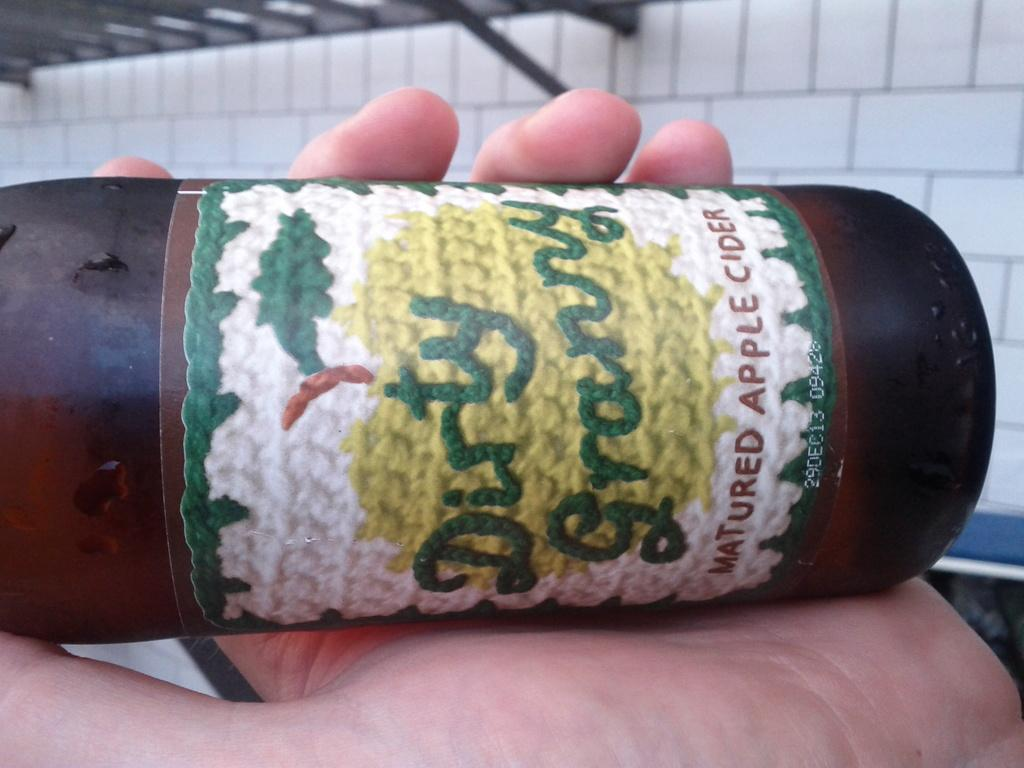<image>
Write a terse but informative summary of the picture. a bottle of Dirty Granny matured apple cider 